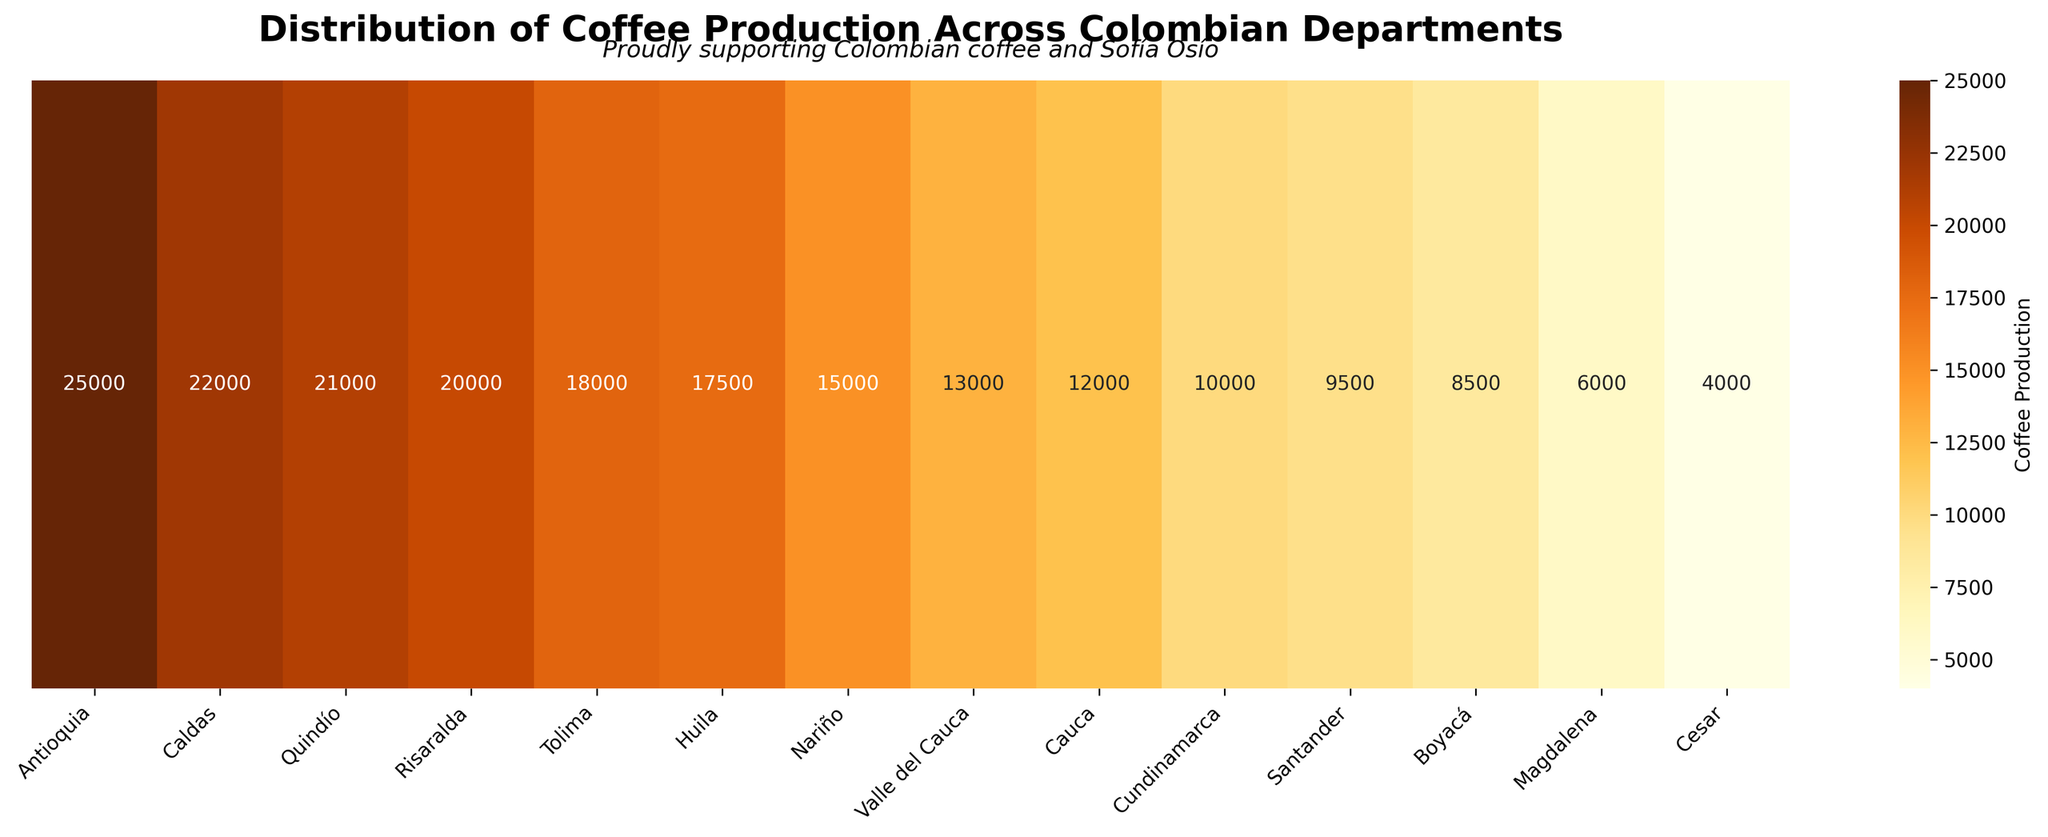Which department has the highest coffee production? The department with the highest coffee production is Antioquia, as indicated by the highest annotated value of 25,000 in the heatmap.
Answer: Antioquia What is the approximate range of coffee production values depicted in the heatmap? The range is determined by the difference between the maximum and minimum values. The highest value is 25,000 (Antioquia) and the lowest is 4,000 (Cesar). So, 25,000 - 4,000 = 21,000.
Answer: 21,000 Which department has the lowest coffee production? The department with the lowest coffee production is Cesar, with an annotated value of 4,000 in the heatmap.
Answer: Cesar How many departments produce more than 15,000 units of coffee? By examining the numbers on the heatmap, the departments with production values greater than 15,000 are Antioquia, Caldas, Quindío, Risaralda, Tolima, Huila, and Nariño. This counts to 7 departments.
Answer: 7 Compare the coffee production between Huila and Nariño. Which one produces more? The heatmap shows that Huila produces 17,500 units and Nariño produces 15,000 units. Therefore, Huila produces more.
Answer: Huila By how much does the coffee production of Antioquia exceed that of Santander? Antioquia produces 25,000 units while Santander produces 9,500 units. The difference is 25,000 - 9,500 = 15,500.
Answer: 15,500 What is the average coffee production of the departments listed? Sum the coffee production values and divide by the number of departments: (25000 + 22000 + 21000 + 20000 + 18000 + 17500 + 15000 + 13000 + 12000 + 10000 + 9500 + 8500 + 6000 + 4000) / 14 = 180,000 / 14 ≈ 12,857.14.
Answer: ~12,857 Which departments have coffee production values between 10,000 and 20,000? Referring to the heatmap, departments with production values in this range are Risaralda (20,000), Tolima (18,000), Huila (17,500), Nariño (15,000), Valle del Cauca (13,000), and Cauca (12,000), Cundinamarca (10,000).
Answer: Risaralda, Tolima, Huila, Nariño, Valle del Cauca, Cauca, Cundinamarca What is the median coffee production value among the departments? Arranging the production values: 4,000, 6,000, 8,500, 9,500, 10,000, 12,000, 13,000, 15,000, 17,500, 18,000, 20,000, 21,000, 22,000, 25,000. There are 14 values, so the median is the average of the 7th and 8th values (13,000 and 15,000). (13,000 + 15,000) / 2 = 14,000.
Answer: 14,000 Which department is the closest to the average coffee production? The average coffee production is approximately 12,857 units. The department with a value closest to this is Cauca, with 12,000 units.
Answer: Cauca 